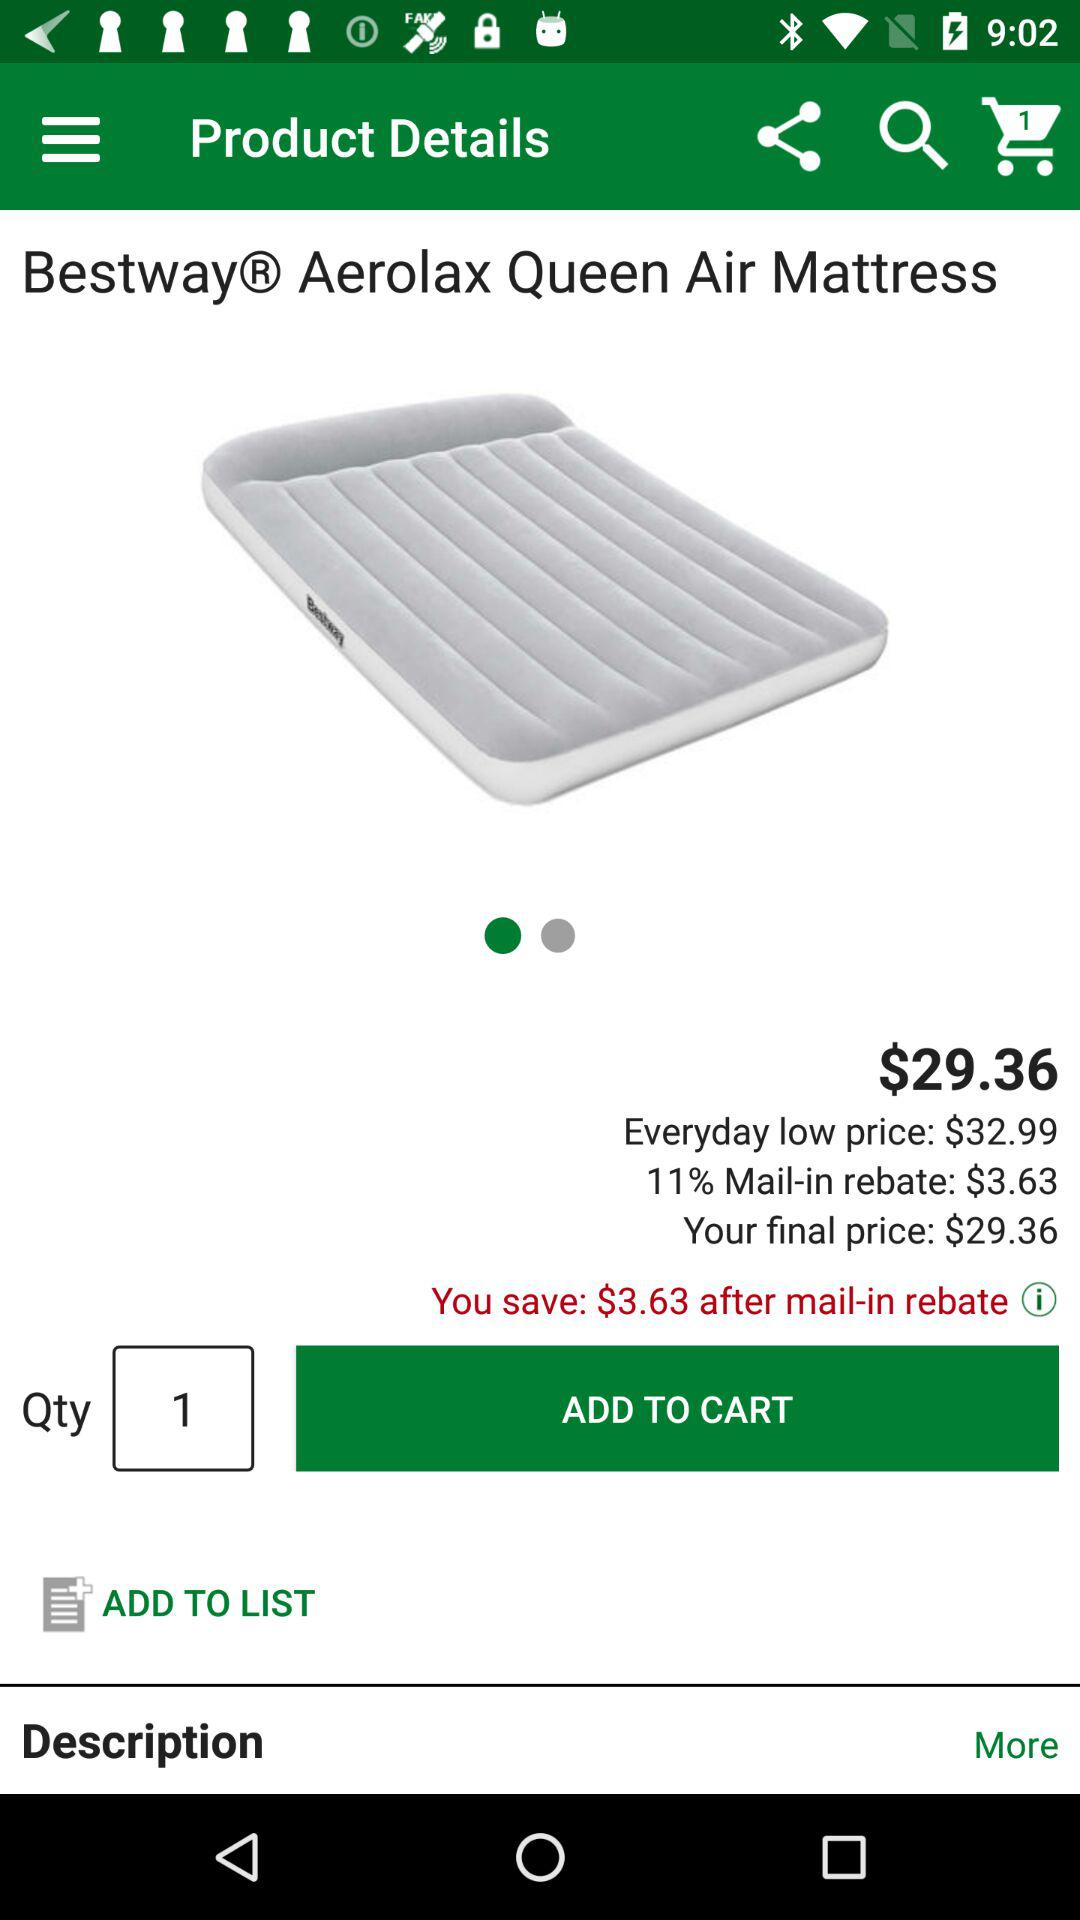How much is saved after the mail-in rebate? You saved $3.63 after the mail-in rebate. 